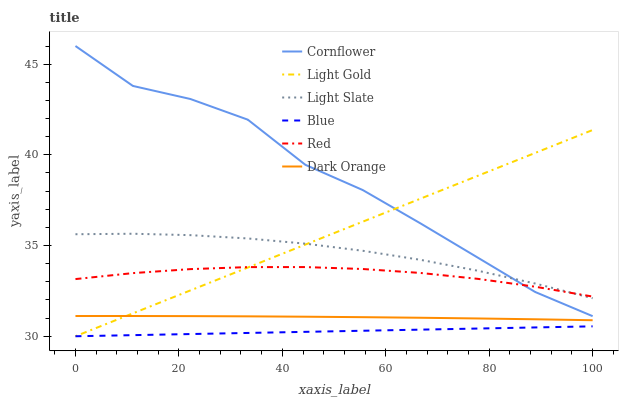Does Blue have the minimum area under the curve?
Answer yes or no. Yes. Does Cornflower have the maximum area under the curve?
Answer yes or no. Yes. Does Dark Orange have the minimum area under the curve?
Answer yes or no. No. Does Dark Orange have the maximum area under the curve?
Answer yes or no. No. Is Blue the smoothest?
Answer yes or no. Yes. Is Cornflower the roughest?
Answer yes or no. Yes. Is Dark Orange the smoothest?
Answer yes or no. No. Is Dark Orange the roughest?
Answer yes or no. No. Does Blue have the lowest value?
Answer yes or no. Yes. Does Cornflower have the lowest value?
Answer yes or no. No. Does Cornflower have the highest value?
Answer yes or no. Yes. Does Dark Orange have the highest value?
Answer yes or no. No. Is Blue less than Cornflower?
Answer yes or no. Yes. Is Light Slate greater than Dark Orange?
Answer yes or no. Yes. Does Light Gold intersect Light Slate?
Answer yes or no. Yes. Is Light Gold less than Light Slate?
Answer yes or no. No. Is Light Gold greater than Light Slate?
Answer yes or no. No. Does Blue intersect Cornflower?
Answer yes or no. No. 